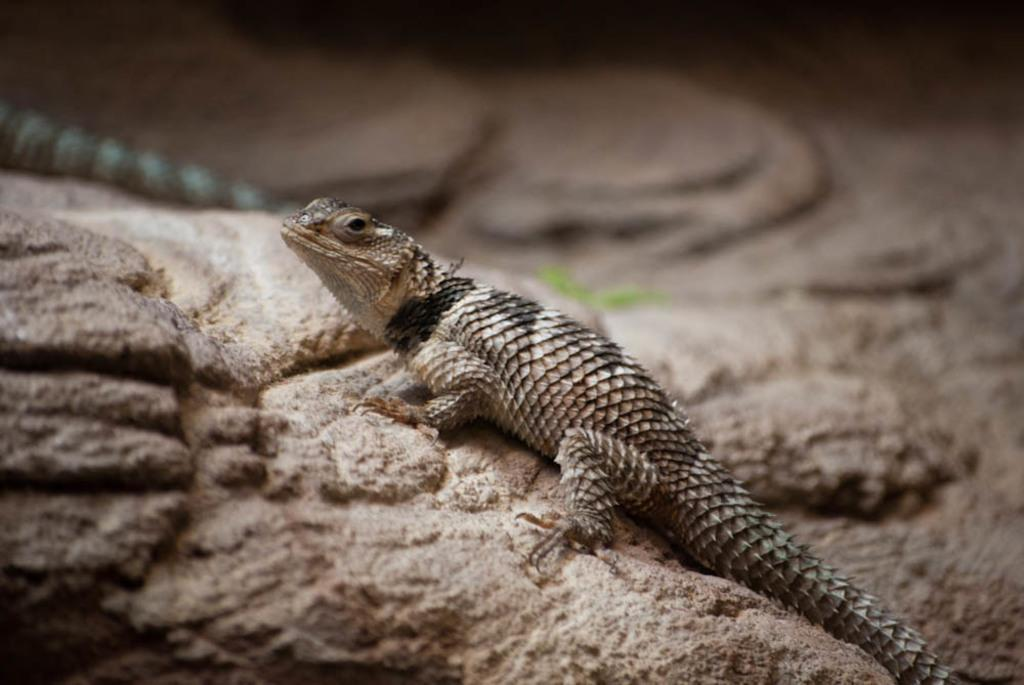What type of animal is in the image? There is a lizard in the image. Where is the lizard located? The lizard is on a stone. How many babies are being rewarded with lumber in the image? There are no babies, rewards, or lumber present in the image; it only features a lizard on a stone. 